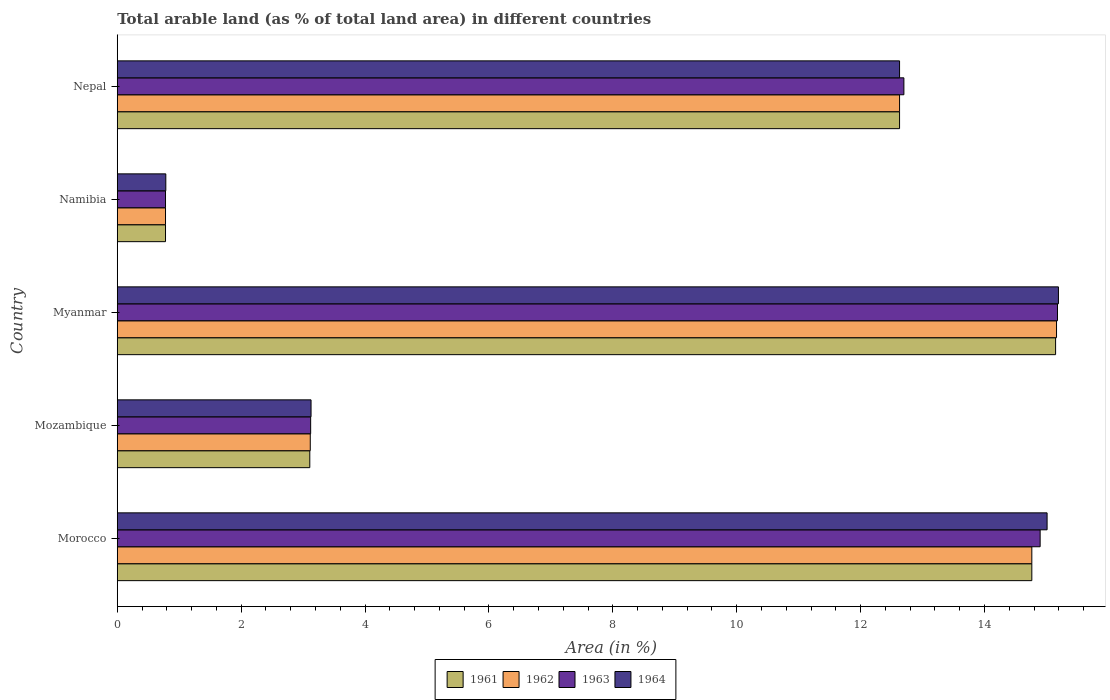How many groups of bars are there?
Ensure brevity in your answer.  5. Are the number of bars on each tick of the Y-axis equal?
Offer a terse response. Yes. How many bars are there on the 1st tick from the top?
Offer a very short reply. 4. How many bars are there on the 3rd tick from the bottom?
Keep it short and to the point. 4. What is the label of the 5th group of bars from the top?
Keep it short and to the point. Morocco. What is the percentage of arable land in 1962 in Mozambique?
Your answer should be very brief. 3.12. Across all countries, what is the maximum percentage of arable land in 1963?
Keep it short and to the point. 15.18. Across all countries, what is the minimum percentage of arable land in 1964?
Keep it short and to the point. 0.78. In which country was the percentage of arable land in 1963 maximum?
Give a very brief answer. Myanmar. In which country was the percentage of arable land in 1962 minimum?
Provide a short and direct response. Namibia. What is the total percentage of arable land in 1962 in the graph?
Offer a very short reply. 46.45. What is the difference between the percentage of arable land in 1963 in Morocco and that in Mozambique?
Your answer should be very brief. 11.78. What is the difference between the percentage of arable land in 1962 in Myanmar and the percentage of arable land in 1963 in Nepal?
Offer a terse response. 2.46. What is the average percentage of arable land in 1963 per country?
Provide a short and direct response. 9.34. What is the difference between the percentage of arable land in 1963 and percentage of arable land in 1964 in Morocco?
Provide a short and direct response. -0.11. What is the ratio of the percentage of arable land in 1962 in Morocco to that in Nepal?
Your response must be concise. 1.17. What is the difference between the highest and the second highest percentage of arable land in 1963?
Give a very brief answer. 0.28. What is the difference between the highest and the lowest percentage of arable land in 1964?
Offer a terse response. 14.41. Is it the case that in every country, the sum of the percentage of arable land in 1962 and percentage of arable land in 1963 is greater than the sum of percentage of arable land in 1961 and percentage of arable land in 1964?
Your answer should be very brief. No. What does the 2nd bar from the top in Mozambique represents?
Make the answer very short. 1963. Is it the case that in every country, the sum of the percentage of arable land in 1963 and percentage of arable land in 1962 is greater than the percentage of arable land in 1964?
Your response must be concise. Yes. Are all the bars in the graph horizontal?
Provide a short and direct response. Yes. How many countries are there in the graph?
Provide a succinct answer. 5. What is the difference between two consecutive major ticks on the X-axis?
Provide a short and direct response. 2. Are the values on the major ticks of X-axis written in scientific E-notation?
Give a very brief answer. No. Does the graph contain any zero values?
Make the answer very short. No. Does the graph contain grids?
Offer a very short reply. No. How many legend labels are there?
Provide a succinct answer. 4. What is the title of the graph?
Give a very brief answer. Total arable land (as % of total land area) in different countries. What is the label or title of the X-axis?
Give a very brief answer. Area (in %). What is the label or title of the Y-axis?
Your answer should be compact. Country. What is the Area (in %) of 1961 in Morocco?
Provide a short and direct response. 14.76. What is the Area (in %) of 1962 in Morocco?
Offer a terse response. 14.76. What is the Area (in %) of 1963 in Morocco?
Make the answer very short. 14.9. What is the Area (in %) in 1964 in Morocco?
Provide a succinct answer. 15.01. What is the Area (in %) in 1961 in Mozambique?
Ensure brevity in your answer.  3.11. What is the Area (in %) of 1962 in Mozambique?
Make the answer very short. 3.12. What is the Area (in %) in 1963 in Mozambique?
Keep it short and to the point. 3.12. What is the Area (in %) of 1964 in Mozambique?
Provide a succinct answer. 3.13. What is the Area (in %) in 1961 in Myanmar?
Provide a short and direct response. 15.15. What is the Area (in %) of 1962 in Myanmar?
Provide a succinct answer. 15.16. What is the Area (in %) of 1963 in Myanmar?
Your response must be concise. 15.18. What is the Area (in %) of 1964 in Myanmar?
Ensure brevity in your answer.  15.19. What is the Area (in %) of 1961 in Namibia?
Your answer should be compact. 0.78. What is the Area (in %) in 1962 in Namibia?
Make the answer very short. 0.78. What is the Area (in %) in 1963 in Namibia?
Ensure brevity in your answer.  0.78. What is the Area (in %) of 1964 in Namibia?
Keep it short and to the point. 0.78. What is the Area (in %) in 1961 in Nepal?
Give a very brief answer. 12.63. What is the Area (in %) in 1962 in Nepal?
Offer a terse response. 12.63. What is the Area (in %) of 1963 in Nepal?
Give a very brief answer. 12.7. What is the Area (in %) of 1964 in Nepal?
Provide a short and direct response. 12.63. Across all countries, what is the maximum Area (in %) of 1961?
Ensure brevity in your answer.  15.15. Across all countries, what is the maximum Area (in %) of 1962?
Ensure brevity in your answer.  15.16. Across all countries, what is the maximum Area (in %) in 1963?
Provide a short and direct response. 15.18. Across all countries, what is the maximum Area (in %) in 1964?
Offer a very short reply. 15.19. Across all countries, what is the minimum Area (in %) in 1961?
Offer a terse response. 0.78. Across all countries, what is the minimum Area (in %) in 1962?
Your response must be concise. 0.78. Across all countries, what is the minimum Area (in %) in 1963?
Provide a short and direct response. 0.78. Across all countries, what is the minimum Area (in %) of 1964?
Offer a very short reply. 0.78. What is the total Area (in %) of 1961 in the graph?
Provide a succinct answer. 46.43. What is the total Area (in %) of 1962 in the graph?
Give a very brief answer. 46.45. What is the total Area (in %) in 1963 in the graph?
Keep it short and to the point. 46.68. What is the total Area (in %) of 1964 in the graph?
Your answer should be compact. 46.75. What is the difference between the Area (in %) of 1961 in Morocco and that in Mozambique?
Your answer should be very brief. 11.66. What is the difference between the Area (in %) in 1962 in Morocco and that in Mozambique?
Make the answer very short. 11.65. What is the difference between the Area (in %) of 1963 in Morocco and that in Mozambique?
Make the answer very short. 11.78. What is the difference between the Area (in %) in 1964 in Morocco and that in Mozambique?
Give a very brief answer. 11.88. What is the difference between the Area (in %) of 1961 in Morocco and that in Myanmar?
Give a very brief answer. -0.38. What is the difference between the Area (in %) in 1962 in Morocco and that in Myanmar?
Your answer should be very brief. -0.4. What is the difference between the Area (in %) in 1963 in Morocco and that in Myanmar?
Your answer should be very brief. -0.28. What is the difference between the Area (in %) in 1964 in Morocco and that in Myanmar?
Keep it short and to the point. -0.18. What is the difference between the Area (in %) of 1961 in Morocco and that in Namibia?
Give a very brief answer. 13.99. What is the difference between the Area (in %) in 1962 in Morocco and that in Namibia?
Keep it short and to the point. 13.99. What is the difference between the Area (in %) in 1963 in Morocco and that in Namibia?
Ensure brevity in your answer.  14.12. What is the difference between the Area (in %) in 1964 in Morocco and that in Namibia?
Provide a short and direct response. 14.23. What is the difference between the Area (in %) in 1961 in Morocco and that in Nepal?
Provide a short and direct response. 2.14. What is the difference between the Area (in %) of 1962 in Morocco and that in Nepal?
Provide a succinct answer. 2.14. What is the difference between the Area (in %) in 1963 in Morocco and that in Nepal?
Offer a very short reply. 2.2. What is the difference between the Area (in %) in 1964 in Morocco and that in Nepal?
Give a very brief answer. 2.38. What is the difference between the Area (in %) in 1961 in Mozambique and that in Myanmar?
Your answer should be compact. -12.04. What is the difference between the Area (in %) in 1962 in Mozambique and that in Myanmar?
Make the answer very short. -12.05. What is the difference between the Area (in %) in 1963 in Mozambique and that in Myanmar?
Provide a short and direct response. -12.06. What is the difference between the Area (in %) in 1964 in Mozambique and that in Myanmar?
Your answer should be very brief. -12.07. What is the difference between the Area (in %) in 1961 in Mozambique and that in Namibia?
Provide a succinct answer. 2.33. What is the difference between the Area (in %) in 1962 in Mozambique and that in Namibia?
Ensure brevity in your answer.  2.34. What is the difference between the Area (in %) of 1963 in Mozambique and that in Namibia?
Your answer should be compact. 2.34. What is the difference between the Area (in %) in 1964 in Mozambique and that in Namibia?
Your answer should be very brief. 2.34. What is the difference between the Area (in %) of 1961 in Mozambique and that in Nepal?
Your response must be concise. -9.52. What is the difference between the Area (in %) of 1962 in Mozambique and that in Nepal?
Give a very brief answer. -9.51. What is the difference between the Area (in %) in 1963 in Mozambique and that in Nepal?
Ensure brevity in your answer.  -9.58. What is the difference between the Area (in %) in 1964 in Mozambique and that in Nepal?
Your response must be concise. -9.5. What is the difference between the Area (in %) of 1961 in Myanmar and that in Namibia?
Provide a succinct answer. 14.37. What is the difference between the Area (in %) of 1962 in Myanmar and that in Namibia?
Give a very brief answer. 14.38. What is the difference between the Area (in %) of 1963 in Myanmar and that in Namibia?
Make the answer very short. 14.4. What is the difference between the Area (in %) in 1964 in Myanmar and that in Namibia?
Your answer should be very brief. 14.41. What is the difference between the Area (in %) in 1961 in Myanmar and that in Nepal?
Offer a very short reply. 2.52. What is the difference between the Area (in %) in 1962 in Myanmar and that in Nepal?
Give a very brief answer. 2.53. What is the difference between the Area (in %) in 1963 in Myanmar and that in Nepal?
Offer a very short reply. 2.48. What is the difference between the Area (in %) in 1964 in Myanmar and that in Nepal?
Your answer should be compact. 2.56. What is the difference between the Area (in %) in 1961 in Namibia and that in Nepal?
Your response must be concise. -11.85. What is the difference between the Area (in %) in 1962 in Namibia and that in Nepal?
Offer a terse response. -11.85. What is the difference between the Area (in %) of 1963 in Namibia and that in Nepal?
Keep it short and to the point. -11.92. What is the difference between the Area (in %) of 1964 in Namibia and that in Nepal?
Your answer should be very brief. -11.85. What is the difference between the Area (in %) of 1961 in Morocco and the Area (in %) of 1962 in Mozambique?
Provide a succinct answer. 11.65. What is the difference between the Area (in %) in 1961 in Morocco and the Area (in %) in 1963 in Mozambique?
Your response must be concise. 11.64. What is the difference between the Area (in %) in 1961 in Morocco and the Area (in %) in 1964 in Mozambique?
Your answer should be very brief. 11.64. What is the difference between the Area (in %) of 1962 in Morocco and the Area (in %) of 1963 in Mozambique?
Provide a short and direct response. 11.64. What is the difference between the Area (in %) of 1962 in Morocco and the Area (in %) of 1964 in Mozambique?
Your response must be concise. 11.64. What is the difference between the Area (in %) in 1963 in Morocco and the Area (in %) in 1964 in Mozambique?
Provide a succinct answer. 11.77. What is the difference between the Area (in %) in 1961 in Morocco and the Area (in %) in 1962 in Myanmar?
Offer a terse response. -0.4. What is the difference between the Area (in %) in 1961 in Morocco and the Area (in %) in 1963 in Myanmar?
Provide a succinct answer. -0.41. What is the difference between the Area (in %) in 1961 in Morocco and the Area (in %) in 1964 in Myanmar?
Your response must be concise. -0.43. What is the difference between the Area (in %) of 1962 in Morocco and the Area (in %) of 1963 in Myanmar?
Keep it short and to the point. -0.41. What is the difference between the Area (in %) in 1962 in Morocco and the Area (in %) in 1964 in Myanmar?
Make the answer very short. -0.43. What is the difference between the Area (in %) of 1963 in Morocco and the Area (in %) of 1964 in Myanmar?
Provide a short and direct response. -0.3. What is the difference between the Area (in %) in 1961 in Morocco and the Area (in %) in 1962 in Namibia?
Give a very brief answer. 13.99. What is the difference between the Area (in %) of 1961 in Morocco and the Area (in %) of 1963 in Namibia?
Keep it short and to the point. 13.99. What is the difference between the Area (in %) in 1961 in Morocco and the Area (in %) in 1964 in Namibia?
Ensure brevity in your answer.  13.98. What is the difference between the Area (in %) in 1962 in Morocco and the Area (in %) in 1963 in Namibia?
Provide a short and direct response. 13.99. What is the difference between the Area (in %) in 1962 in Morocco and the Area (in %) in 1964 in Namibia?
Give a very brief answer. 13.98. What is the difference between the Area (in %) of 1963 in Morocco and the Area (in %) of 1964 in Namibia?
Offer a terse response. 14.12. What is the difference between the Area (in %) in 1961 in Morocco and the Area (in %) in 1962 in Nepal?
Provide a succinct answer. 2.14. What is the difference between the Area (in %) in 1961 in Morocco and the Area (in %) in 1963 in Nepal?
Offer a very short reply. 2.07. What is the difference between the Area (in %) in 1961 in Morocco and the Area (in %) in 1964 in Nepal?
Your answer should be compact. 2.14. What is the difference between the Area (in %) of 1962 in Morocco and the Area (in %) of 1963 in Nepal?
Offer a very short reply. 2.07. What is the difference between the Area (in %) of 1962 in Morocco and the Area (in %) of 1964 in Nepal?
Ensure brevity in your answer.  2.14. What is the difference between the Area (in %) in 1963 in Morocco and the Area (in %) in 1964 in Nepal?
Ensure brevity in your answer.  2.27. What is the difference between the Area (in %) in 1961 in Mozambique and the Area (in %) in 1962 in Myanmar?
Provide a succinct answer. -12.06. What is the difference between the Area (in %) in 1961 in Mozambique and the Area (in %) in 1963 in Myanmar?
Keep it short and to the point. -12.07. What is the difference between the Area (in %) in 1961 in Mozambique and the Area (in %) in 1964 in Myanmar?
Offer a very short reply. -12.09. What is the difference between the Area (in %) of 1962 in Mozambique and the Area (in %) of 1963 in Myanmar?
Your answer should be very brief. -12.06. What is the difference between the Area (in %) of 1962 in Mozambique and the Area (in %) of 1964 in Myanmar?
Keep it short and to the point. -12.08. What is the difference between the Area (in %) of 1963 in Mozambique and the Area (in %) of 1964 in Myanmar?
Your answer should be very brief. -12.07. What is the difference between the Area (in %) of 1961 in Mozambique and the Area (in %) of 1962 in Namibia?
Your answer should be very brief. 2.33. What is the difference between the Area (in %) in 1961 in Mozambique and the Area (in %) in 1963 in Namibia?
Offer a very short reply. 2.33. What is the difference between the Area (in %) in 1961 in Mozambique and the Area (in %) in 1964 in Namibia?
Offer a very short reply. 2.32. What is the difference between the Area (in %) of 1962 in Mozambique and the Area (in %) of 1963 in Namibia?
Ensure brevity in your answer.  2.34. What is the difference between the Area (in %) in 1962 in Mozambique and the Area (in %) in 1964 in Namibia?
Offer a very short reply. 2.33. What is the difference between the Area (in %) of 1963 in Mozambique and the Area (in %) of 1964 in Namibia?
Provide a succinct answer. 2.34. What is the difference between the Area (in %) in 1961 in Mozambique and the Area (in %) in 1962 in Nepal?
Ensure brevity in your answer.  -9.52. What is the difference between the Area (in %) in 1961 in Mozambique and the Area (in %) in 1963 in Nepal?
Provide a short and direct response. -9.59. What is the difference between the Area (in %) in 1961 in Mozambique and the Area (in %) in 1964 in Nepal?
Provide a short and direct response. -9.52. What is the difference between the Area (in %) in 1962 in Mozambique and the Area (in %) in 1963 in Nepal?
Make the answer very short. -9.58. What is the difference between the Area (in %) in 1962 in Mozambique and the Area (in %) in 1964 in Nepal?
Your response must be concise. -9.51. What is the difference between the Area (in %) in 1963 in Mozambique and the Area (in %) in 1964 in Nepal?
Make the answer very short. -9.51. What is the difference between the Area (in %) of 1961 in Myanmar and the Area (in %) of 1962 in Namibia?
Provide a short and direct response. 14.37. What is the difference between the Area (in %) in 1961 in Myanmar and the Area (in %) in 1963 in Namibia?
Make the answer very short. 14.37. What is the difference between the Area (in %) in 1961 in Myanmar and the Area (in %) in 1964 in Namibia?
Make the answer very short. 14.36. What is the difference between the Area (in %) in 1962 in Myanmar and the Area (in %) in 1963 in Namibia?
Your response must be concise. 14.38. What is the difference between the Area (in %) of 1962 in Myanmar and the Area (in %) of 1964 in Namibia?
Your response must be concise. 14.38. What is the difference between the Area (in %) of 1963 in Myanmar and the Area (in %) of 1964 in Namibia?
Provide a short and direct response. 14.4. What is the difference between the Area (in %) of 1961 in Myanmar and the Area (in %) of 1962 in Nepal?
Provide a short and direct response. 2.52. What is the difference between the Area (in %) of 1961 in Myanmar and the Area (in %) of 1963 in Nepal?
Your answer should be very brief. 2.45. What is the difference between the Area (in %) in 1961 in Myanmar and the Area (in %) in 1964 in Nepal?
Offer a terse response. 2.52. What is the difference between the Area (in %) of 1962 in Myanmar and the Area (in %) of 1963 in Nepal?
Make the answer very short. 2.46. What is the difference between the Area (in %) in 1962 in Myanmar and the Area (in %) in 1964 in Nepal?
Give a very brief answer. 2.53. What is the difference between the Area (in %) in 1963 in Myanmar and the Area (in %) in 1964 in Nepal?
Offer a terse response. 2.55. What is the difference between the Area (in %) in 1961 in Namibia and the Area (in %) in 1962 in Nepal?
Your response must be concise. -11.85. What is the difference between the Area (in %) in 1961 in Namibia and the Area (in %) in 1963 in Nepal?
Your answer should be very brief. -11.92. What is the difference between the Area (in %) of 1961 in Namibia and the Area (in %) of 1964 in Nepal?
Provide a succinct answer. -11.85. What is the difference between the Area (in %) of 1962 in Namibia and the Area (in %) of 1963 in Nepal?
Your answer should be very brief. -11.92. What is the difference between the Area (in %) of 1962 in Namibia and the Area (in %) of 1964 in Nepal?
Your answer should be compact. -11.85. What is the difference between the Area (in %) of 1963 in Namibia and the Area (in %) of 1964 in Nepal?
Your response must be concise. -11.85. What is the average Area (in %) of 1961 per country?
Ensure brevity in your answer.  9.29. What is the average Area (in %) of 1962 per country?
Ensure brevity in your answer.  9.29. What is the average Area (in %) of 1963 per country?
Provide a short and direct response. 9.34. What is the average Area (in %) of 1964 per country?
Keep it short and to the point. 9.35. What is the difference between the Area (in %) in 1961 and Area (in %) in 1962 in Morocco?
Give a very brief answer. 0. What is the difference between the Area (in %) of 1961 and Area (in %) of 1963 in Morocco?
Make the answer very short. -0.13. What is the difference between the Area (in %) in 1961 and Area (in %) in 1964 in Morocco?
Ensure brevity in your answer.  -0.25. What is the difference between the Area (in %) in 1962 and Area (in %) in 1963 in Morocco?
Ensure brevity in your answer.  -0.13. What is the difference between the Area (in %) of 1962 and Area (in %) of 1964 in Morocco?
Provide a short and direct response. -0.25. What is the difference between the Area (in %) in 1963 and Area (in %) in 1964 in Morocco?
Offer a terse response. -0.11. What is the difference between the Area (in %) in 1961 and Area (in %) in 1962 in Mozambique?
Make the answer very short. -0.01. What is the difference between the Area (in %) in 1961 and Area (in %) in 1963 in Mozambique?
Provide a succinct answer. -0.01. What is the difference between the Area (in %) in 1961 and Area (in %) in 1964 in Mozambique?
Offer a very short reply. -0.02. What is the difference between the Area (in %) in 1962 and Area (in %) in 1963 in Mozambique?
Offer a terse response. -0.01. What is the difference between the Area (in %) of 1962 and Area (in %) of 1964 in Mozambique?
Provide a short and direct response. -0.01. What is the difference between the Area (in %) of 1963 and Area (in %) of 1964 in Mozambique?
Provide a short and direct response. -0.01. What is the difference between the Area (in %) of 1961 and Area (in %) of 1962 in Myanmar?
Your response must be concise. -0.02. What is the difference between the Area (in %) in 1961 and Area (in %) in 1963 in Myanmar?
Give a very brief answer. -0.03. What is the difference between the Area (in %) of 1961 and Area (in %) of 1964 in Myanmar?
Your response must be concise. -0.05. What is the difference between the Area (in %) in 1962 and Area (in %) in 1963 in Myanmar?
Your answer should be very brief. -0.02. What is the difference between the Area (in %) in 1962 and Area (in %) in 1964 in Myanmar?
Your response must be concise. -0.03. What is the difference between the Area (in %) of 1963 and Area (in %) of 1964 in Myanmar?
Make the answer very short. -0.02. What is the difference between the Area (in %) in 1961 and Area (in %) in 1962 in Namibia?
Offer a very short reply. 0. What is the difference between the Area (in %) in 1961 and Area (in %) in 1963 in Namibia?
Your response must be concise. 0. What is the difference between the Area (in %) of 1961 and Area (in %) of 1964 in Namibia?
Make the answer very short. -0. What is the difference between the Area (in %) of 1962 and Area (in %) of 1963 in Namibia?
Provide a short and direct response. 0. What is the difference between the Area (in %) of 1962 and Area (in %) of 1964 in Namibia?
Your answer should be compact. -0. What is the difference between the Area (in %) in 1963 and Area (in %) in 1964 in Namibia?
Your response must be concise. -0. What is the difference between the Area (in %) in 1961 and Area (in %) in 1962 in Nepal?
Keep it short and to the point. 0. What is the difference between the Area (in %) in 1961 and Area (in %) in 1963 in Nepal?
Your answer should be compact. -0.07. What is the difference between the Area (in %) in 1962 and Area (in %) in 1963 in Nepal?
Make the answer very short. -0.07. What is the difference between the Area (in %) of 1962 and Area (in %) of 1964 in Nepal?
Your answer should be compact. 0. What is the difference between the Area (in %) of 1963 and Area (in %) of 1964 in Nepal?
Keep it short and to the point. 0.07. What is the ratio of the Area (in %) of 1961 in Morocco to that in Mozambique?
Ensure brevity in your answer.  4.75. What is the ratio of the Area (in %) of 1962 in Morocco to that in Mozambique?
Give a very brief answer. 4.74. What is the ratio of the Area (in %) in 1963 in Morocco to that in Mozambique?
Provide a short and direct response. 4.77. What is the ratio of the Area (in %) of 1964 in Morocco to that in Mozambique?
Make the answer very short. 4.8. What is the ratio of the Area (in %) of 1961 in Morocco to that in Myanmar?
Your answer should be very brief. 0.97. What is the ratio of the Area (in %) of 1962 in Morocco to that in Myanmar?
Provide a succinct answer. 0.97. What is the ratio of the Area (in %) in 1963 in Morocco to that in Myanmar?
Offer a very short reply. 0.98. What is the ratio of the Area (in %) in 1964 in Morocco to that in Myanmar?
Give a very brief answer. 0.99. What is the ratio of the Area (in %) in 1961 in Morocco to that in Namibia?
Offer a terse response. 18.96. What is the ratio of the Area (in %) in 1962 in Morocco to that in Namibia?
Ensure brevity in your answer.  18.96. What is the ratio of the Area (in %) in 1963 in Morocco to that in Namibia?
Offer a very short reply. 19.14. What is the ratio of the Area (in %) of 1964 in Morocco to that in Namibia?
Offer a terse response. 19.16. What is the ratio of the Area (in %) in 1961 in Morocco to that in Nepal?
Provide a short and direct response. 1.17. What is the ratio of the Area (in %) in 1962 in Morocco to that in Nepal?
Your response must be concise. 1.17. What is the ratio of the Area (in %) of 1963 in Morocco to that in Nepal?
Provide a succinct answer. 1.17. What is the ratio of the Area (in %) of 1964 in Morocco to that in Nepal?
Keep it short and to the point. 1.19. What is the ratio of the Area (in %) in 1961 in Mozambique to that in Myanmar?
Offer a very short reply. 0.21. What is the ratio of the Area (in %) of 1962 in Mozambique to that in Myanmar?
Offer a terse response. 0.21. What is the ratio of the Area (in %) in 1963 in Mozambique to that in Myanmar?
Offer a very short reply. 0.21. What is the ratio of the Area (in %) in 1964 in Mozambique to that in Myanmar?
Provide a short and direct response. 0.21. What is the ratio of the Area (in %) in 1961 in Mozambique to that in Namibia?
Provide a short and direct response. 3.99. What is the ratio of the Area (in %) of 1962 in Mozambique to that in Namibia?
Ensure brevity in your answer.  4. What is the ratio of the Area (in %) in 1963 in Mozambique to that in Namibia?
Your response must be concise. 4.01. What is the ratio of the Area (in %) in 1964 in Mozambique to that in Namibia?
Your response must be concise. 3.99. What is the ratio of the Area (in %) in 1961 in Mozambique to that in Nepal?
Provide a short and direct response. 0.25. What is the ratio of the Area (in %) in 1962 in Mozambique to that in Nepal?
Offer a very short reply. 0.25. What is the ratio of the Area (in %) of 1963 in Mozambique to that in Nepal?
Provide a short and direct response. 0.25. What is the ratio of the Area (in %) in 1964 in Mozambique to that in Nepal?
Provide a short and direct response. 0.25. What is the ratio of the Area (in %) of 1961 in Myanmar to that in Namibia?
Your answer should be compact. 19.46. What is the ratio of the Area (in %) in 1962 in Myanmar to that in Namibia?
Your answer should be very brief. 19.48. What is the ratio of the Area (in %) of 1963 in Myanmar to that in Namibia?
Give a very brief answer. 19.5. What is the ratio of the Area (in %) of 1964 in Myanmar to that in Namibia?
Your answer should be compact. 19.39. What is the ratio of the Area (in %) of 1961 in Myanmar to that in Nepal?
Ensure brevity in your answer.  1.2. What is the ratio of the Area (in %) in 1962 in Myanmar to that in Nepal?
Ensure brevity in your answer.  1.2. What is the ratio of the Area (in %) in 1963 in Myanmar to that in Nepal?
Make the answer very short. 1.2. What is the ratio of the Area (in %) of 1964 in Myanmar to that in Nepal?
Ensure brevity in your answer.  1.2. What is the ratio of the Area (in %) of 1961 in Namibia to that in Nepal?
Your answer should be compact. 0.06. What is the ratio of the Area (in %) in 1962 in Namibia to that in Nepal?
Your answer should be compact. 0.06. What is the ratio of the Area (in %) of 1963 in Namibia to that in Nepal?
Provide a succinct answer. 0.06. What is the ratio of the Area (in %) in 1964 in Namibia to that in Nepal?
Your response must be concise. 0.06. What is the difference between the highest and the second highest Area (in %) in 1961?
Provide a short and direct response. 0.38. What is the difference between the highest and the second highest Area (in %) of 1962?
Make the answer very short. 0.4. What is the difference between the highest and the second highest Area (in %) of 1963?
Give a very brief answer. 0.28. What is the difference between the highest and the second highest Area (in %) of 1964?
Give a very brief answer. 0.18. What is the difference between the highest and the lowest Area (in %) of 1961?
Keep it short and to the point. 14.37. What is the difference between the highest and the lowest Area (in %) of 1962?
Keep it short and to the point. 14.38. What is the difference between the highest and the lowest Area (in %) in 1963?
Offer a very short reply. 14.4. What is the difference between the highest and the lowest Area (in %) of 1964?
Ensure brevity in your answer.  14.41. 